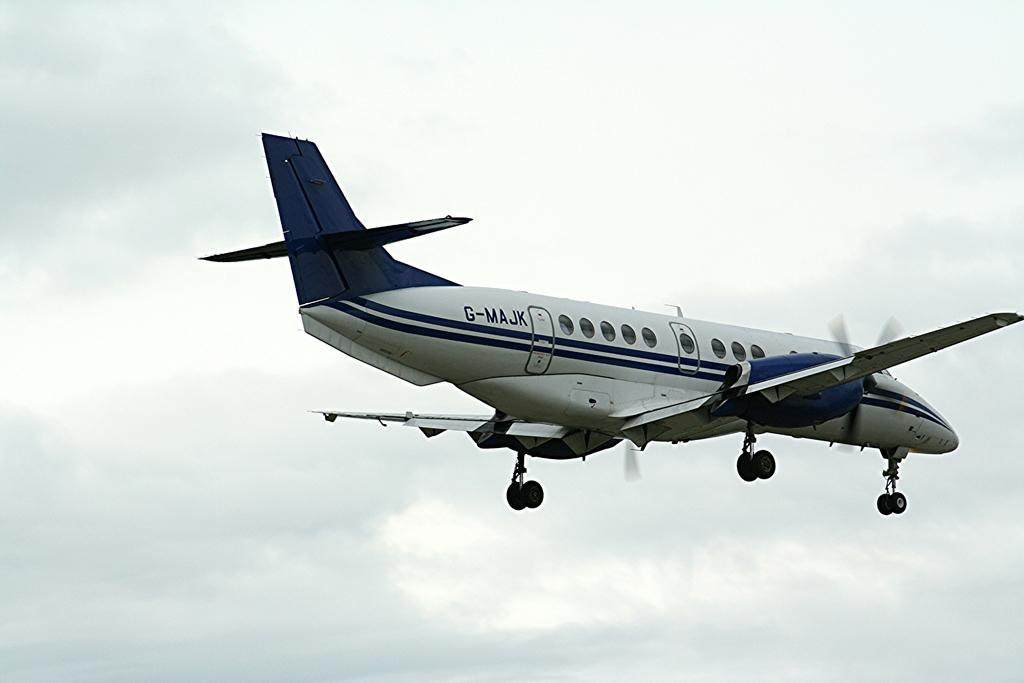<image>
Relay a brief, clear account of the picture shown. White and blue plane in the air with the plate G-MAJK on it's back. 